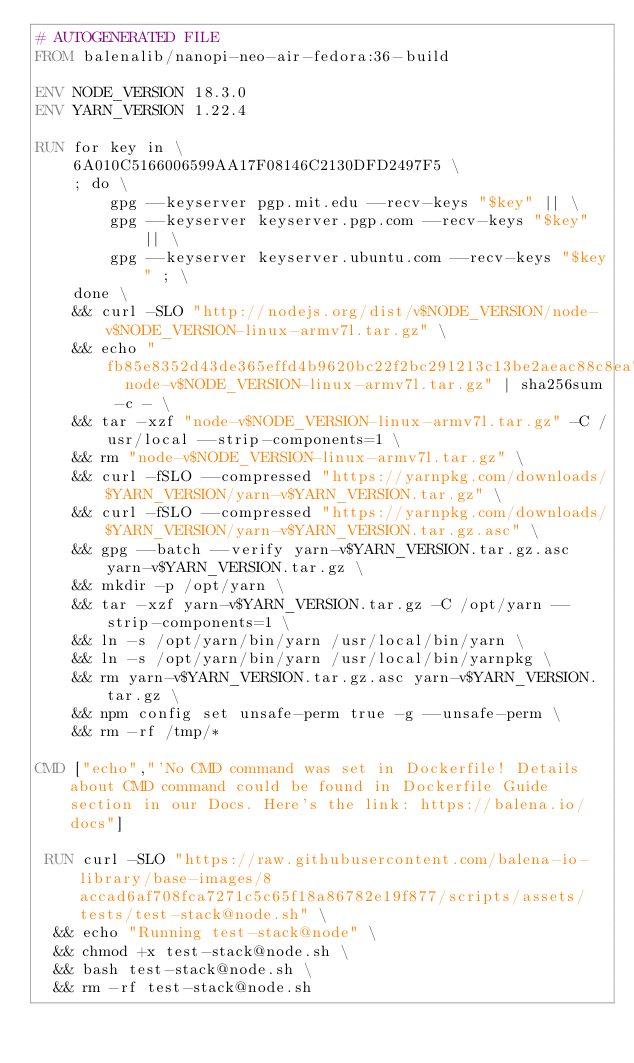Convert code to text. <code><loc_0><loc_0><loc_500><loc_500><_Dockerfile_># AUTOGENERATED FILE
FROM balenalib/nanopi-neo-air-fedora:36-build

ENV NODE_VERSION 18.3.0
ENV YARN_VERSION 1.22.4

RUN for key in \
	6A010C5166006599AA17F08146C2130DFD2497F5 \
	; do \
		gpg --keyserver pgp.mit.edu --recv-keys "$key" || \
		gpg --keyserver keyserver.pgp.com --recv-keys "$key" || \
		gpg --keyserver keyserver.ubuntu.com --recv-keys "$key" ; \
	done \
	&& curl -SLO "http://nodejs.org/dist/v$NODE_VERSION/node-v$NODE_VERSION-linux-armv7l.tar.gz" \
	&& echo "fb85e8352d43de365effd4b9620bc22f2bc291213c13be2aeac88c8ea741c5ce  node-v$NODE_VERSION-linux-armv7l.tar.gz" | sha256sum -c - \
	&& tar -xzf "node-v$NODE_VERSION-linux-armv7l.tar.gz" -C /usr/local --strip-components=1 \
	&& rm "node-v$NODE_VERSION-linux-armv7l.tar.gz" \
	&& curl -fSLO --compressed "https://yarnpkg.com/downloads/$YARN_VERSION/yarn-v$YARN_VERSION.tar.gz" \
	&& curl -fSLO --compressed "https://yarnpkg.com/downloads/$YARN_VERSION/yarn-v$YARN_VERSION.tar.gz.asc" \
	&& gpg --batch --verify yarn-v$YARN_VERSION.tar.gz.asc yarn-v$YARN_VERSION.tar.gz \
	&& mkdir -p /opt/yarn \
	&& tar -xzf yarn-v$YARN_VERSION.tar.gz -C /opt/yarn --strip-components=1 \
	&& ln -s /opt/yarn/bin/yarn /usr/local/bin/yarn \
	&& ln -s /opt/yarn/bin/yarn /usr/local/bin/yarnpkg \
	&& rm yarn-v$YARN_VERSION.tar.gz.asc yarn-v$YARN_VERSION.tar.gz \
	&& npm config set unsafe-perm true -g --unsafe-perm \
	&& rm -rf /tmp/*

CMD ["echo","'No CMD command was set in Dockerfile! Details about CMD command could be found in Dockerfile Guide section in our Docs. Here's the link: https://balena.io/docs"]

 RUN curl -SLO "https://raw.githubusercontent.com/balena-io-library/base-images/8accad6af708fca7271c5c65f18a86782e19f877/scripts/assets/tests/test-stack@node.sh" \
  && echo "Running test-stack@node" \
  && chmod +x test-stack@node.sh \
  && bash test-stack@node.sh \
  && rm -rf test-stack@node.sh 
</code> 